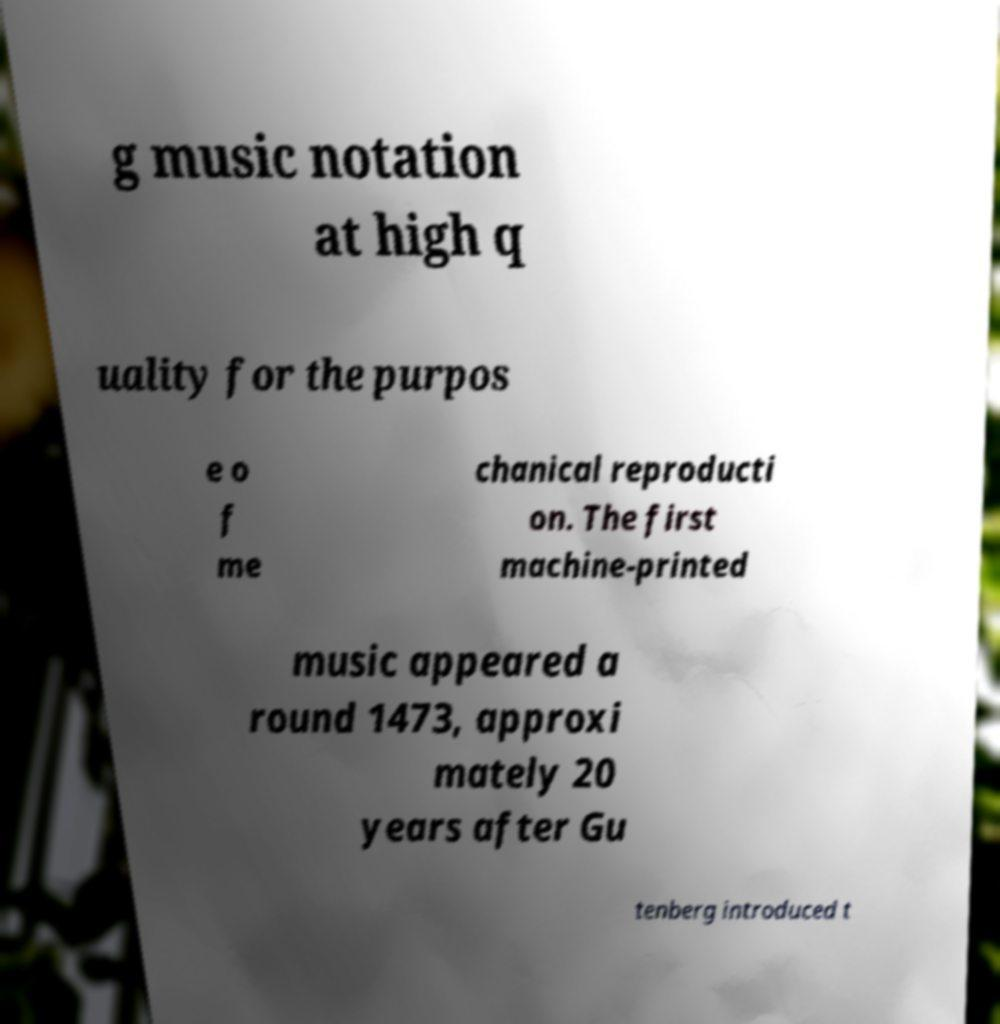Can you accurately transcribe the text from the provided image for me? g music notation at high q uality for the purpos e o f me chanical reproducti on. The first machine-printed music appeared a round 1473, approxi mately 20 years after Gu tenberg introduced t 